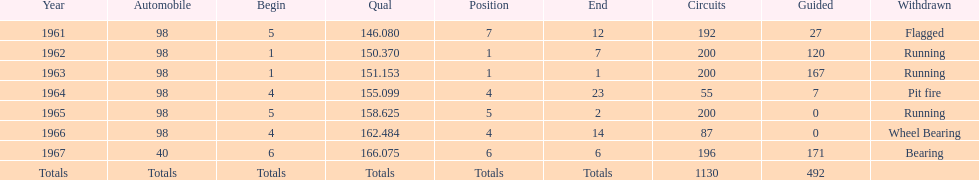In how many indy 500 races, has jones been flagged? 1. 